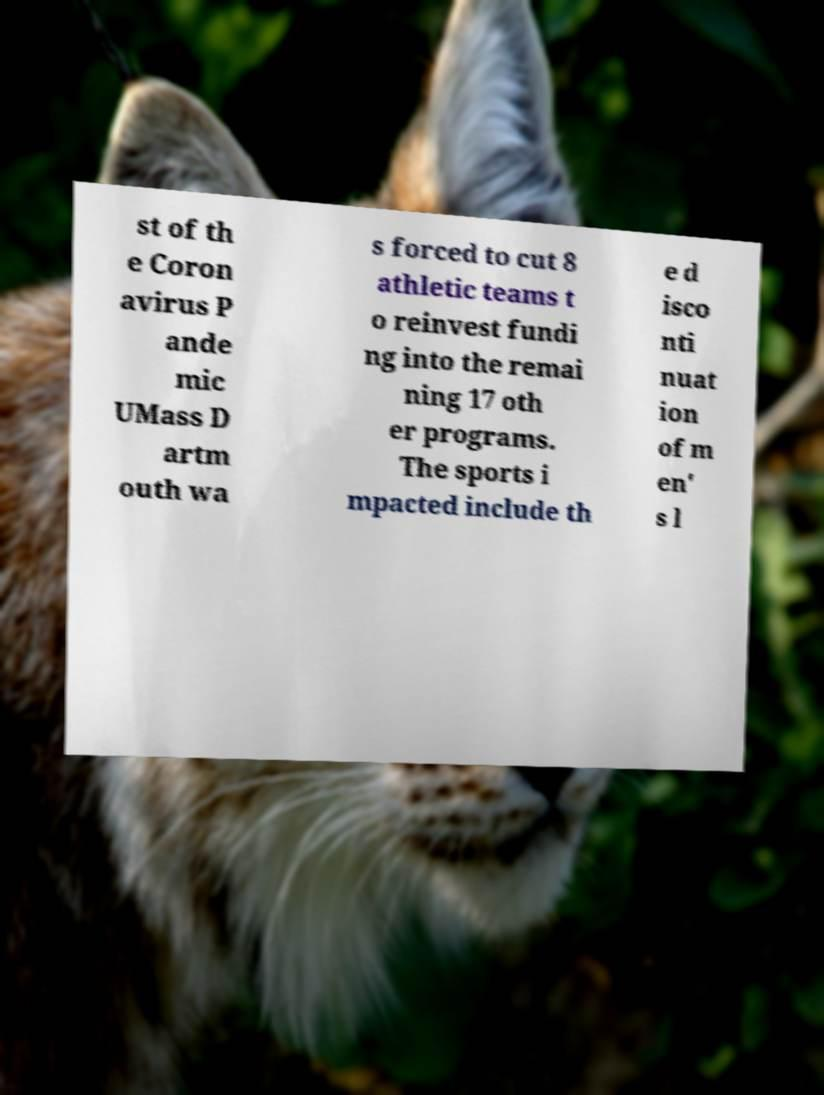What messages or text are displayed in this image? I need them in a readable, typed format. st of th e Coron avirus P ande mic UMass D artm outh wa s forced to cut 8 athletic teams t o reinvest fundi ng into the remai ning 17 oth er programs. The sports i mpacted include th e d isco nti nuat ion of m en' s l 